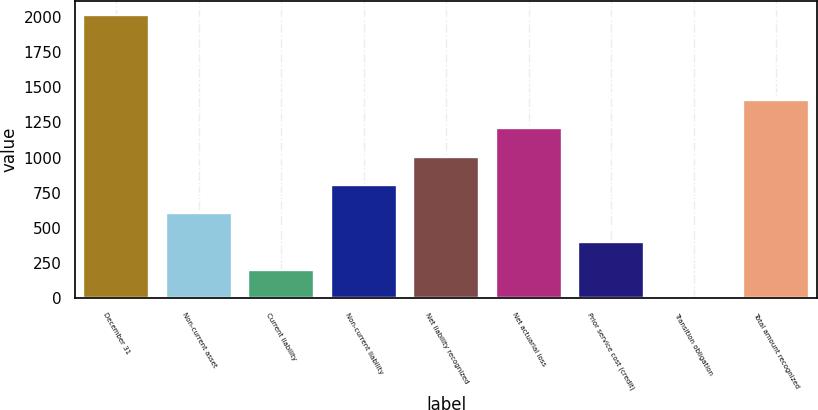Convert chart to OTSL. <chart><loc_0><loc_0><loc_500><loc_500><bar_chart><fcel>December 31<fcel>Non-current asset<fcel>Current liability<fcel>Non-current liability<fcel>Net liability recognized<fcel>Net actuarial loss<fcel>Prior service cost (credit)<fcel>Transition obligation<fcel>Total amount recognized<nl><fcel>2012<fcel>604.55<fcel>202.41<fcel>805.62<fcel>1006.69<fcel>1207.76<fcel>403.48<fcel>1.34<fcel>1408.83<nl></chart> 